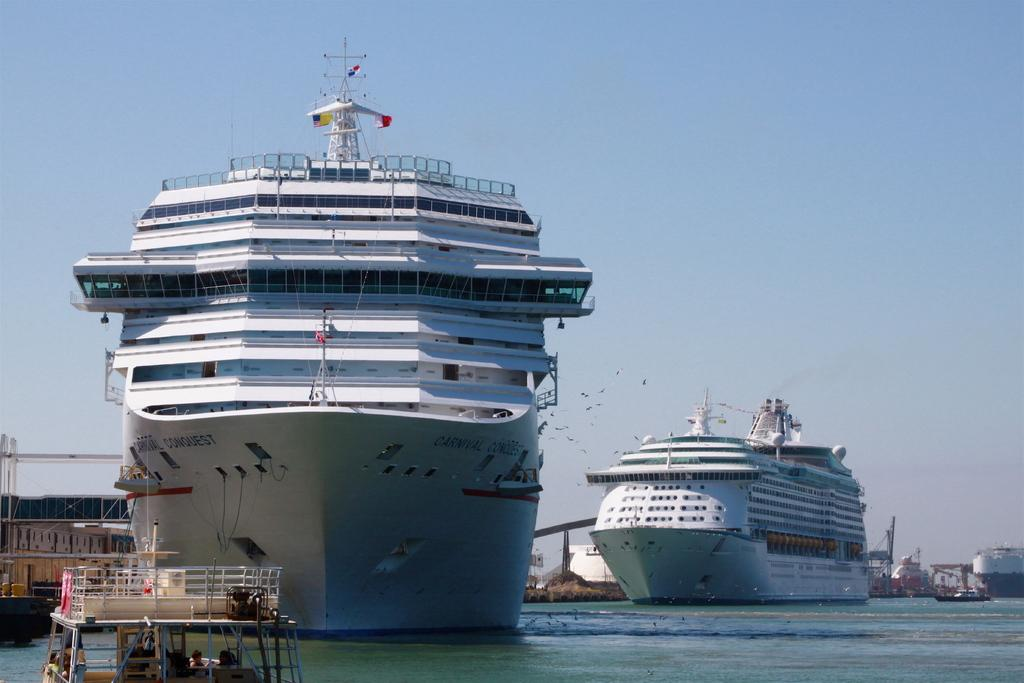What types of watercraft are present in the image? There are ships with flags and boats on the water in the image. What can be seen in the background of the image? The sky is visible in the background of the image. What country is the ocean in the image located near? There is no ocean present in the image; it features ships and boats on water, but the specific body of water is not identified. 